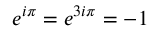Convert formula to latex. <formula><loc_0><loc_0><loc_500><loc_500>e ^ { i \pi } = e ^ { 3 i \pi } = - 1</formula> 